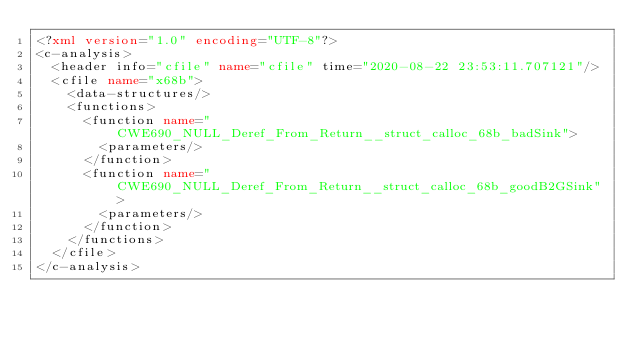Convert code to text. <code><loc_0><loc_0><loc_500><loc_500><_XML_><?xml version="1.0" encoding="UTF-8"?>
<c-analysis>
  <header info="cfile" name="cfile" time="2020-08-22 23:53:11.707121"/>
  <cfile name="x68b">
    <data-structures/>
    <functions>
      <function name="CWE690_NULL_Deref_From_Return__struct_calloc_68b_badSink">
        <parameters/>
      </function>
      <function name="CWE690_NULL_Deref_From_Return__struct_calloc_68b_goodB2GSink">
        <parameters/>
      </function>
    </functions>
  </cfile>
</c-analysis>
</code> 